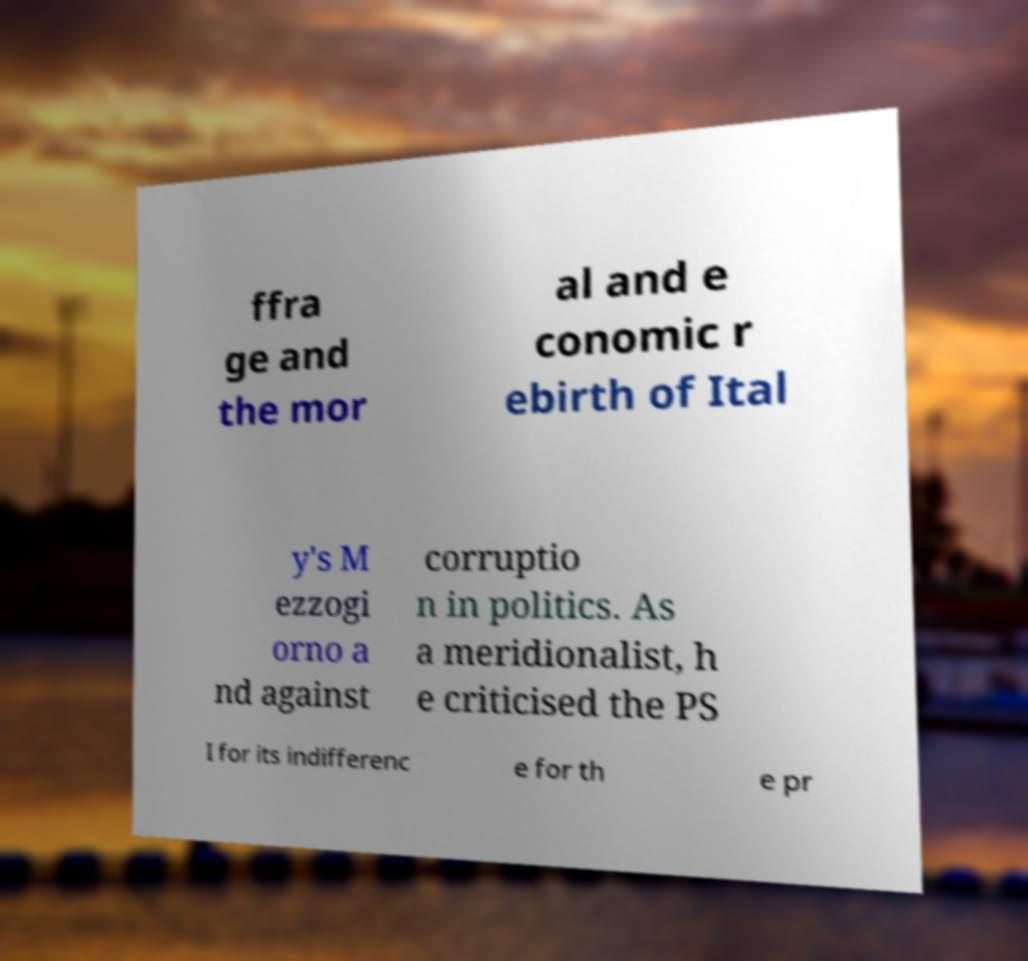I need the written content from this picture converted into text. Can you do that? ffra ge and the mor al and e conomic r ebirth of Ital y's M ezzogi orno a nd against corruptio n in politics. As a meridionalist, h e criticised the PS I for its indifferenc e for th e pr 